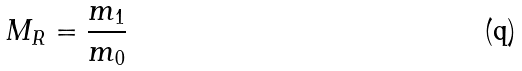Convert formula to latex. <formula><loc_0><loc_0><loc_500><loc_500>M _ { R } = \frac { m _ { 1 } } { m _ { 0 } }</formula> 